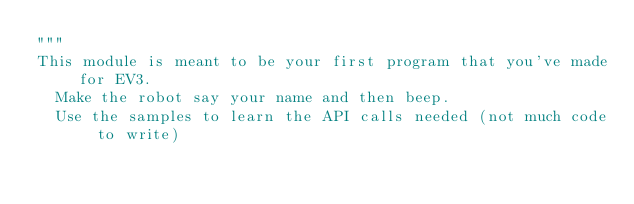Convert code to text. <code><loc_0><loc_0><loc_500><loc_500><_Python_>"""
This module is meant to be your first program that you've made for EV3.
  Make the robot say your name and then beep.
  Use the samples to learn the API calls needed (not much code to write)
</code> 